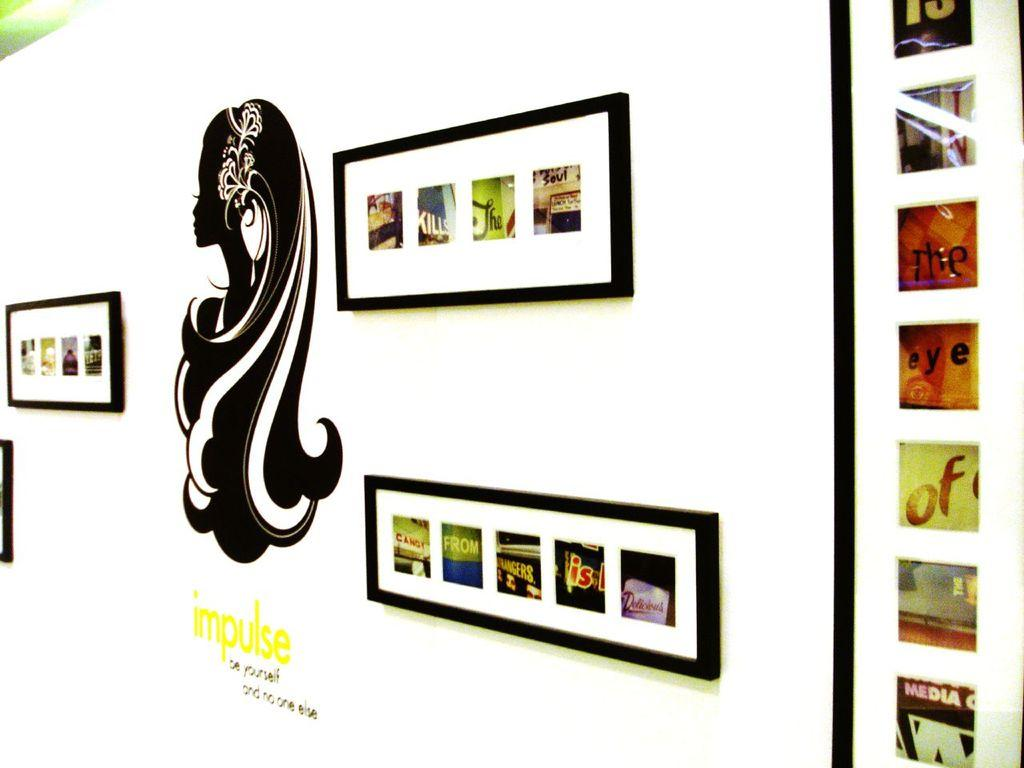<image>
Render a clear and concise summary of the photo. Art work with a saying impulse be yourself and no one else under it. 